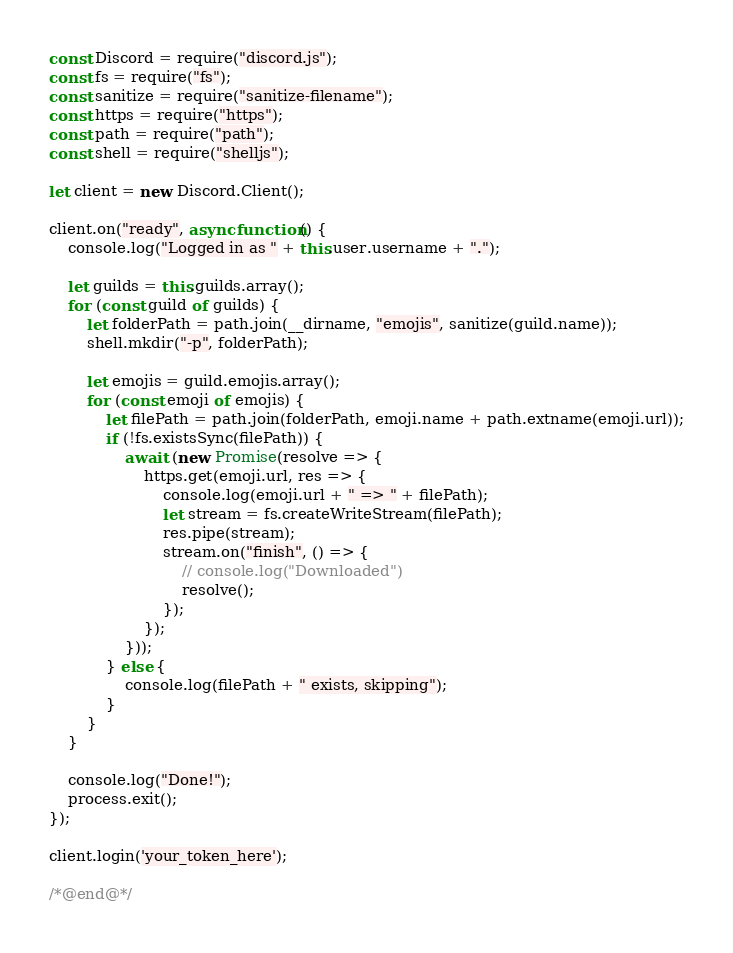Convert code to text. <code><loc_0><loc_0><loc_500><loc_500><_JavaScript_>
const Discord = require("discord.js");
const fs = require("fs");
const sanitize = require("sanitize-filename");
const https = require("https");
const path = require("path");
const shell = require("shelljs");

let client = new Discord.Client();

client.on("ready", async function() {
    console.log("Logged in as " + this.user.username + ".");

    let guilds = this.guilds.array();
    for (const guild of guilds) {
        let folderPath = path.join(__dirname, "emojis", sanitize(guild.name));
        shell.mkdir("-p", folderPath);

        let emojis = guild.emojis.array();
        for (const emoji of emojis) {
            let filePath = path.join(folderPath, emoji.name + path.extname(emoji.url));
            if (!fs.existsSync(filePath)) {
                await (new Promise(resolve => {
                    https.get(emoji.url, res => {
                        console.log(emoji.url + " => " + filePath);
                        let stream = fs.createWriteStream(filePath);
                        res.pipe(stream);
                        stream.on("finish", () => {
                            // console.log("Downloaded")
                            resolve();
                        });
                    });
                }));
            } else {
                console.log(filePath + " exists, skipping");
            }
        }
    }

    console.log("Done!");
    process.exit();
});

client.login('your_token_here');

/*@end@*/

</code> 